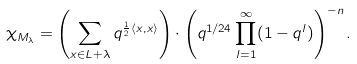Convert formula to latex. <formula><loc_0><loc_0><loc_500><loc_500>\chi _ { M _ { \lambda } } = \left ( \sum _ { x \in L + \lambda } q ^ { \frac { 1 } { 2 } \langle x , x \rangle } \right ) \cdot \left ( q ^ { 1 / 2 4 } \prod _ { l = 1 } ^ { \infty } ( 1 - q ^ { l } ) \right ) ^ { - n } .</formula> 